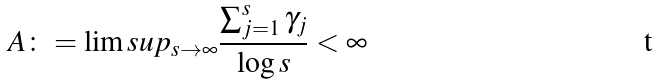Convert formula to latex. <formula><loc_0><loc_0><loc_500><loc_500>A \colon = \lim s u p _ { s \rightarrow \infty } \frac { \sum ^ { s } _ { j = 1 } \gamma _ { j } } { \log s } < \infty</formula> 